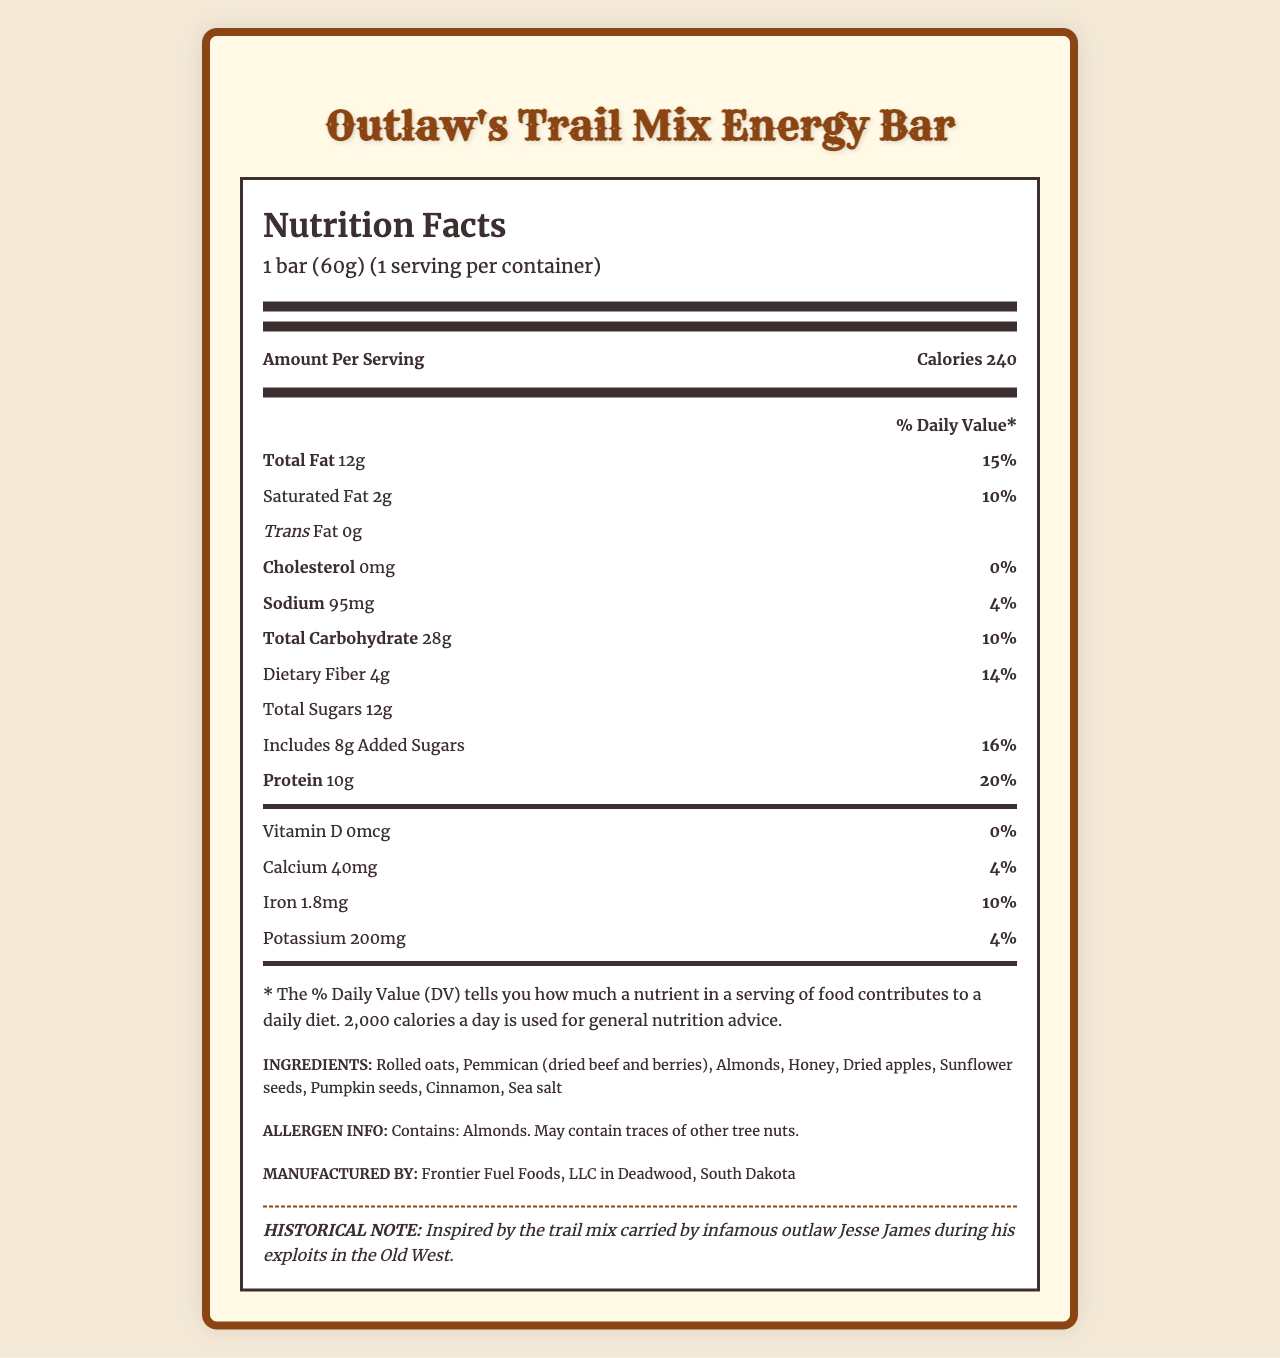what is the serving size of the Outlaw's Trail Mix Energy Bar? The serving size is found in the serving information section at the top of the Nutrition Facts label.
Answer: 1 bar (60g) how much protein does one serving of the energy bar contain? The protein content per serving is listed under the macronutrient breakdown in the Nutrition Facts label.
Answer: 10g which ingredient in the energy bar is the primary source of protein? According to the document, pemmican (dried beef) is listed as a protein source under the protein sources section.
Answer: Pemmican (dried beef) what is the percent daily value of dietary fiber in the energy bar? The percent daily value for dietary fiber is stated next to its amount under the Total Carbohydrate section of the Nutrition Facts label.
Answer: 14% how many grams of added sugars are in one bar? The amount of added sugars is provided as a sub-category under the Total Sugars section in the Nutrition Facts label.
Answer: 8g which of the following is not an ingredient in the energy bar? A. Almonds B. Peanut Butter C. Dried Apples The ingredients listed in the document include almonds and dried apples, but not peanut butter.
Answer: B what is the historical note provided in the document? The historical note is found at the bottom of the document under a special section labeled "Historical Note."
Answer: Inspired by the trail mix carried by infamous outlaw Jesse James during his exploits in the Old West. is the energy bar gluten-free? The document does not provide information about whether the energy bar is gluten-free.
Answer: Not enough information does the energy bar contain trans fat? Under the macronutrient breakdown section, the label shows that there is 0g of trans fat.
Answer: No summarize the main idea of the Outlaw's Trail Mix Energy Bar's nutrition label. This summary is derived from the entire document including the nutritional content, historical note, and additional information provided in the different sections.
Answer: The Nutrition Facts label provides a detailed breakdown of the nutrient content per serving of the Outlaw's Trail Mix Energy Bar, inspired by Old West flavors and infused with ingredients like pemmican and dried apples. It also includes allergen information, historical context, and manufacturing details. how many calories does the energy bar contain? The calorie count is prominently displayed near the top of the Nutrition Facts section of the document.
Answer: 240 what percentage of the daily value for iron does the energy bar provide? The percent daily value for iron is listed under the micronutrient section in the Nutrition Facts label.
Answer: 10% which company manufactures the energy bar and where is it manufactured? A. Frontier Snacks, LLC in Tombstone, Arizona B. Old West Foods, Inc in Santa Fe, New Mexico C. Frontier Fuel Foods, LLC in Deadwood, South Dakota The manufacturing information is provided at the bottom of the document, specifying Frontier Fuel Foods, LLC in Deadwood, South Dakota as the manufacturer.
Answer: C what are the two main sources of carbohydrates in the energy bar? The carbohydrate sources section lists rolled oats and honey as the main sources of carbohydrates in the energy bar.
Answer: Rolled oats and honey 